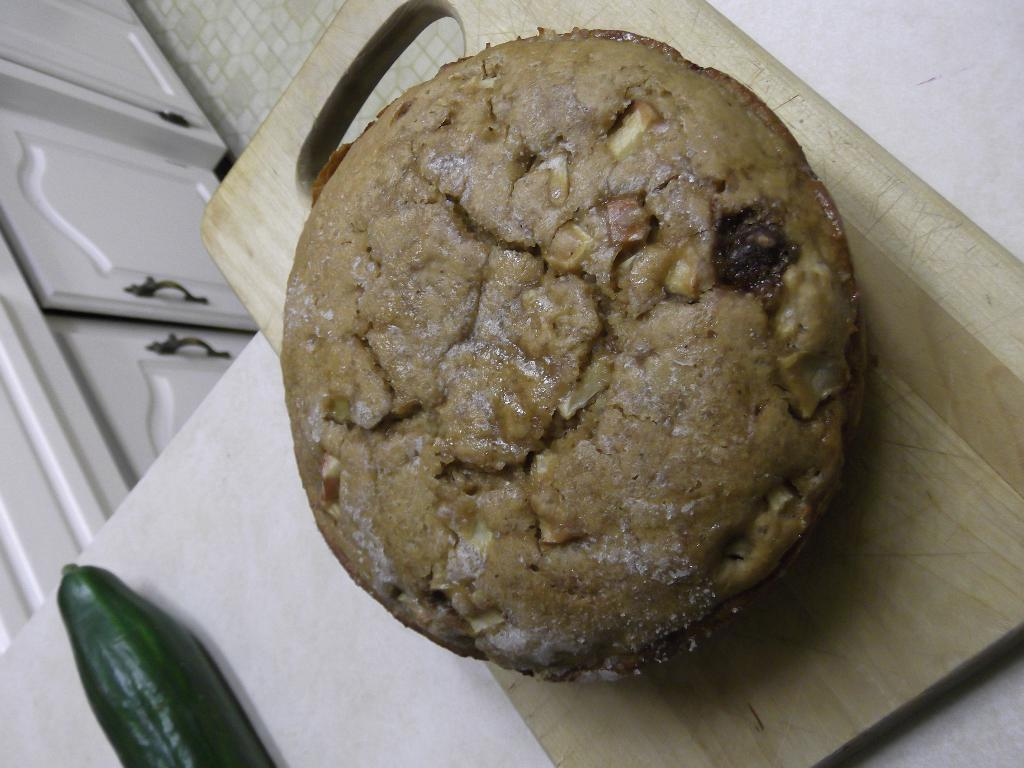What is the main food item featured on the chopper board in the image? There is a cake on a chopper board in the image. What other types of food are present in the image? There are vegetables in the image. How are the cake and vegetables arranged in the image? The cake and vegetables are placed on a white platform. What can be seen in the background of the image? There are cupboards visible in the background of the image. What type of juice is being squeezed from the pigs in the image? There are no pigs or juice present in the image; it features a cake and vegetables on a white platform with cupboards in the background. 